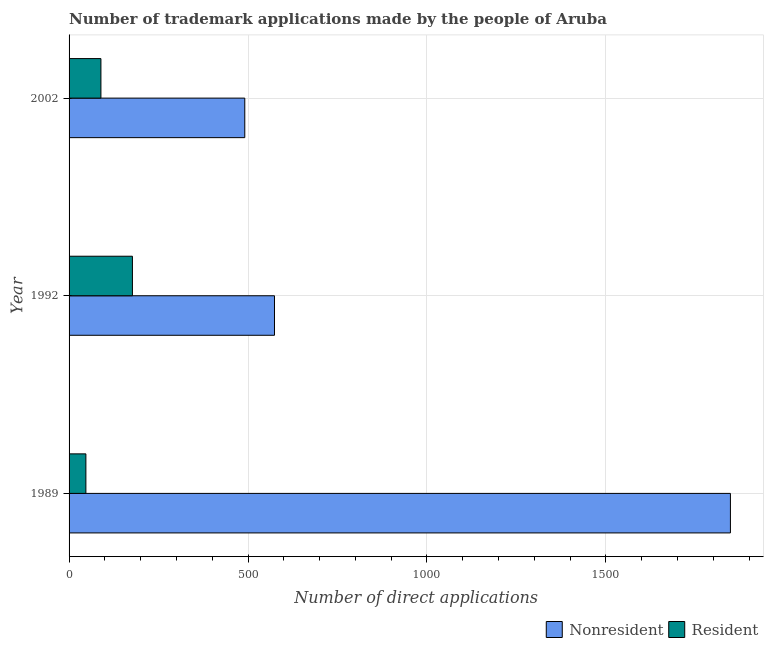How many different coloured bars are there?
Your response must be concise. 2. Are the number of bars on each tick of the Y-axis equal?
Keep it short and to the point. Yes. How many bars are there on the 3rd tick from the top?
Your answer should be compact. 2. What is the label of the 2nd group of bars from the top?
Keep it short and to the point. 1992. What is the number of trademark applications made by residents in 2002?
Provide a short and direct response. 89. Across all years, what is the maximum number of trademark applications made by non residents?
Offer a terse response. 1848. Across all years, what is the minimum number of trademark applications made by residents?
Keep it short and to the point. 47. In which year was the number of trademark applications made by non residents minimum?
Ensure brevity in your answer.  2002. What is the total number of trademark applications made by non residents in the graph?
Give a very brief answer. 2913. What is the difference between the number of trademark applications made by non residents in 1989 and that in 1992?
Make the answer very short. 1274. What is the difference between the number of trademark applications made by residents in 2002 and the number of trademark applications made by non residents in 1989?
Offer a terse response. -1759. What is the average number of trademark applications made by non residents per year?
Your answer should be very brief. 971. In the year 1992, what is the difference between the number of trademark applications made by residents and number of trademark applications made by non residents?
Offer a terse response. -397. In how many years, is the number of trademark applications made by residents greater than 1300 ?
Ensure brevity in your answer.  0. What is the ratio of the number of trademark applications made by residents in 1992 to that in 2002?
Your response must be concise. 1.99. What is the difference between the highest and the second highest number of trademark applications made by non residents?
Ensure brevity in your answer.  1274. What is the difference between the highest and the lowest number of trademark applications made by non residents?
Your answer should be very brief. 1357. In how many years, is the number of trademark applications made by residents greater than the average number of trademark applications made by residents taken over all years?
Ensure brevity in your answer.  1. Is the sum of the number of trademark applications made by non residents in 1989 and 2002 greater than the maximum number of trademark applications made by residents across all years?
Provide a short and direct response. Yes. What does the 2nd bar from the top in 1989 represents?
Provide a short and direct response. Nonresident. What does the 1st bar from the bottom in 1989 represents?
Keep it short and to the point. Nonresident. Are all the bars in the graph horizontal?
Your answer should be very brief. Yes. How many years are there in the graph?
Keep it short and to the point. 3. What is the difference between two consecutive major ticks on the X-axis?
Provide a short and direct response. 500. Does the graph contain any zero values?
Your response must be concise. No. Does the graph contain grids?
Your answer should be very brief. Yes. Where does the legend appear in the graph?
Offer a terse response. Bottom right. How many legend labels are there?
Your response must be concise. 2. What is the title of the graph?
Give a very brief answer. Number of trademark applications made by the people of Aruba. What is the label or title of the X-axis?
Your answer should be compact. Number of direct applications. What is the Number of direct applications of Nonresident in 1989?
Offer a very short reply. 1848. What is the Number of direct applications in Nonresident in 1992?
Provide a short and direct response. 574. What is the Number of direct applications of Resident in 1992?
Offer a terse response. 177. What is the Number of direct applications in Nonresident in 2002?
Offer a very short reply. 491. What is the Number of direct applications in Resident in 2002?
Keep it short and to the point. 89. Across all years, what is the maximum Number of direct applications in Nonresident?
Keep it short and to the point. 1848. Across all years, what is the maximum Number of direct applications in Resident?
Your answer should be very brief. 177. Across all years, what is the minimum Number of direct applications in Nonresident?
Ensure brevity in your answer.  491. Across all years, what is the minimum Number of direct applications of Resident?
Keep it short and to the point. 47. What is the total Number of direct applications of Nonresident in the graph?
Make the answer very short. 2913. What is the total Number of direct applications of Resident in the graph?
Your answer should be compact. 313. What is the difference between the Number of direct applications in Nonresident in 1989 and that in 1992?
Keep it short and to the point. 1274. What is the difference between the Number of direct applications in Resident in 1989 and that in 1992?
Your response must be concise. -130. What is the difference between the Number of direct applications in Nonresident in 1989 and that in 2002?
Offer a terse response. 1357. What is the difference between the Number of direct applications of Resident in 1989 and that in 2002?
Your answer should be very brief. -42. What is the difference between the Number of direct applications of Nonresident in 1992 and that in 2002?
Offer a terse response. 83. What is the difference between the Number of direct applications in Nonresident in 1989 and the Number of direct applications in Resident in 1992?
Offer a very short reply. 1671. What is the difference between the Number of direct applications in Nonresident in 1989 and the Number of direct applications in Resident in 2002?
Give a very brief answer. 1759. What is the difference between the Number of direct applications in Nonresident in 1992 and the Number of direct applications in Resident in 2002?
Your answer should be very brief. 485. What is the average Number of direct applications in Nonresident per year?
Give a very brief answer. 971. What is the average Number of direct applications of Resident per year?
Keep it short and to the point. 104.33. In the year 1989, what is the difference between the Number of direct applications of Nonresident and Number of direct applications of Resident?
Give a very brief answer. 1801. In the year 1992, what is the difference between the Number of direct applications of Nonresident and Number of direct applications of Resident?
Your response must be concise. 397. In the year 2002, what is the difference between the Number of direct applications in Nonresident and Number of direct applications in Resident?
Your answer should be very brief. 402. What is the ratio of the Number of direct applications of Nonresident in 1989 to that in 1992?
Offer a terse response. 3.22. What is the ratio of the Number of direct applications in Resident in 1989 to that in 1992?
Ensure brevity in your answer.  0.27. What is the ratio of the Number of direct applications in Nonresident in 1989 to that in 2002?
Keep it short and to the point. 3.76. What is the ratio of the Number of direct applications of Resident in 1989 to that in 2002?
Your answer should be compact. 0.53. What is the ratio of the Number of direct applications of Nonresident in 1992 to that in 2002?
Keep it short and to the point. 1.17. What is the ratio of the Number of direct applications in Resident in 1992 to that in 2002?
Give a very brief answer. 1.99. What is the difference between the highest and the second highest Number of direct applications in Nonresident?
Make the answer very short. 1274. What is the difference between the highest and the second highest Number of direct applications in Resident?
Keep it short and to the point. 88. What is the difference between the highest and the lowest Number of direct applications in Nonresident?
Give a very brief answer. 1357. What is the difference between the highest and the lowest Number of direct applications in Resident?
Offer a terse response. 130. 